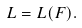Convert formula to latex. <formula><loc_0><loc_0><loc_500><loc_500>L = L ( { F } ) .</formula> 